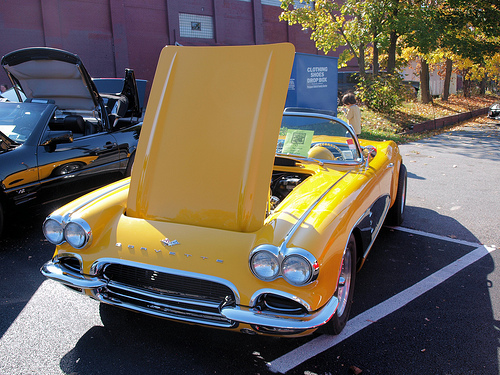<image>
Is the line next to the car? Yes. The line is positioned adjacent to the car, located nearby in the same general area. 